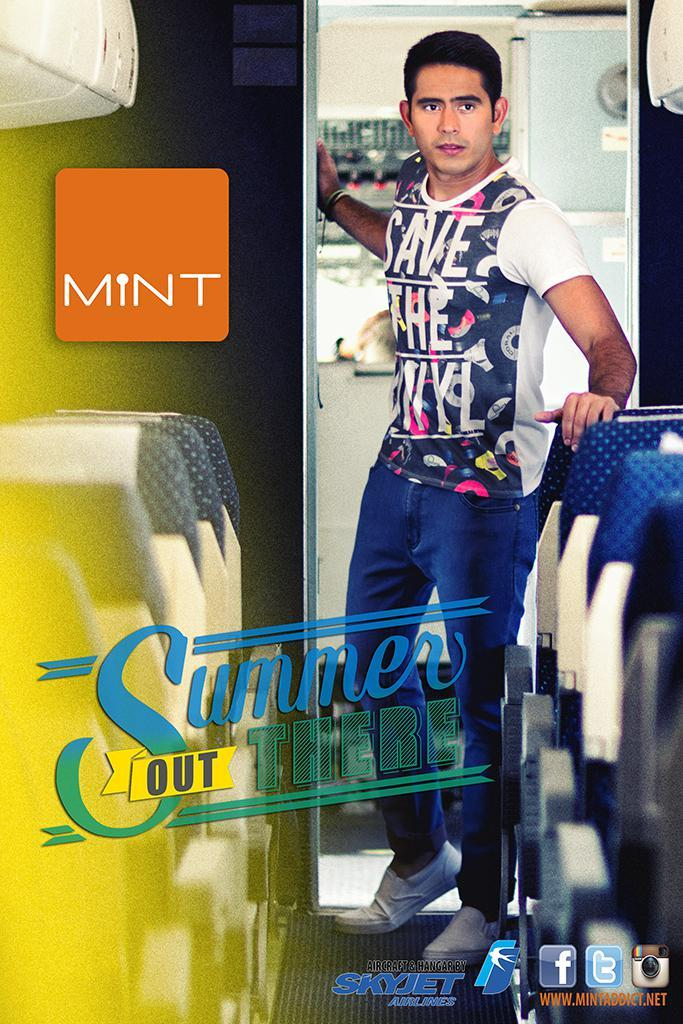Provide a one-sentence caption for the provided image. a man wearing a shirt with save the on it. 